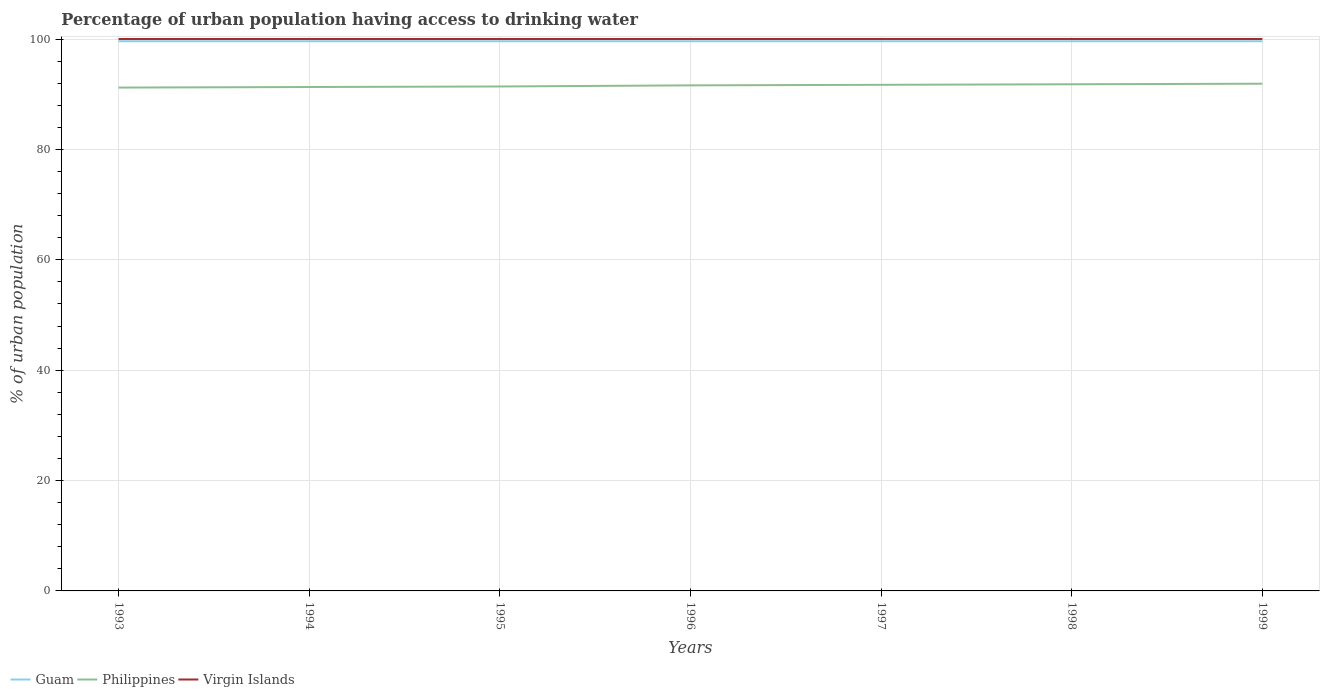Is the number of lines equal to the number of legend labels?
Your response must be concise. Yes. Across all years, what is the maximum percentage of urban population having access to drinking water in Philippines?
Your answer should be very brief. 91.2. How many years are there in the graph?
Give a very brief answer. 7. Does the graph contain grids?
Provide a short and direct response. Yes. Where does the legend appear in the graph?
Your response must be concise. Bottom left. How many legend labels are there?
Offer a terse response. 3. How are the legend labels stacked?
Offer a very short reply. Horizontal. What is the title of the graph?
Provide a short and direct response. Percentage of urban population having access to drinking water. Does "Niger" appear as one of the legend labels in the graph?
Make the answer very short. No. What is the label or title of the X-axis?
Ensure brevity in your answer.  Years. What is the label or title of the Y-axis?
Your response must be concise. % of urban population. What is the % of urban population of Guam in 1993?
Keep it short and to the point. 99.6. What is the % of urban population of Philippines in 1993?
Give a very brief answer. 91.2. What is the % of urban population in Guam in 1994?
Your response must be concise. 99.6. What is the % of urban population in Philippines in 1994?
Provide a succinct answer. 91.3. What is the % of urban population of Guam in 1995?
Give a very brief answer. 99.6. What is the % of urban population in Philippines in 1995?
Keep it short and to the point. 91.4. What is the % of urban population in Guam in 1996?
Your answer should be very brief. 99.6. What is the % of urban population of Philippines in 1996?
Give a very brief answer. 91.6. What is the % of urban population of Virgin Islands in 1996?
Provide a short and direct response. 100. What is the % of urban population in Guam in 1997?
Give a very brief answer. 99.6. What is the % of urban population in Philippines in 1997?
Your answer should be very brief. 91.7. What is the % of urban population of Guam in 1998?
Give a very brief answer. 99.6. What is the % of urban population in Philippines in 1998?
Your answer should be very brief. 91.8. What is the % of urban population of Virgin Islands in 1998?
Offer a very short reply. 100. What is the % of urban population of Guam in 1999?
Offer a very short reply. 99.6. What is the % of urban population in Philippines in 1999?
Keep it short and to the point. 91.9. What is the % of urban population of Virgin Islands in 1999?
Give a very brief answer. 100. Across all years, what is the maximum % of urban population in Guam?
Provide a short and direct response. 99.6. Across all years, what is the maximum % of urban population in Philippines?
Keep it short and to the point. 91.9. Across all years, what is the minimum % of urban population in Guam?
Provide a succinct answer. 99.6. Across all years, what is the minimum % of urban population of Philippines?
Give a very brief answer. 91.2. Across all years, what is the minimum % of urban population of Virgin Islands?
Give a very brief answer. 100. What is the total % of urban population in Guam in the graph?
Your answer should be very brief. 697.2. What is the total % of urban population of Philippines in the graph?
Keep it short and to the point. 640.9. What is the total % of urban population in Virgin Islands in the graph?
Make the answer very short. 700. What is the difference between the % of urban population in Guam in 1993 and that in 1994?
Your response must be concise. 0. What is the difference between the % of urban population in Virgin Islands in 1993 and that in 1994?
Offer a very short reply. 0. What is the difference between the % of urban population in Virgin Islands in 1993 and that in 1995?
Your answer should be very brief. 0. What is the difference between the % of urban population of Philippines in 1993 and that in 1996?
Your answer should be compact. -0.4. What is the difference between the % of urban population in Virgin Islands in 1993 and that in 1997?
Offer a very short reply. 0. What is the difference between the % of urban population of Virgin Islands in 1993 and that in 1998?
Keep it short and to the point. 0. What is the difference between the % of urban population of Philippines in 1993 and that in 1999?
Ensure brevity in your answer.  -0.7. What is the difference between the % of urban population in Virgin Islands in 1993 and that in 1999?
Your answer should be compact. 0. What is the difference between the % of urban population of Guam in 1994 and that in 1995?
Offer a very short reply. 0. What is the difference between the % of urban population in Philippines in 1994 and that in 1997?
Your answer should be very brief. -0.4. What is the difference between the % of urban population in Guam in 1994 and that in 1998?
Your answer should be very brief. 0. What is the difference between the % of urban population in Philippines in 1994 and that in 1998?
Offer a very short reply. -0.5. What is the difference between the % of urban population of Virgin Islands in 1994 and that in 1998?
Provide a succinct answer. 0. What is the difference between the % of urban population of Philippines in 1995 and that in 1996?
Offer a terse response. -0.2. What is the difference between the % of urban population in Guam in 1995 and that in 1997?
Keep it short and to the point. 0. What is the difference between the % of urban population in Philippines in 1995 and that in 1997?
Make the answer very short. -0.3. What is the difference between the % of urban population in Guam in 1995 and that in 1998?
Make the answer very short. 0. What is the difference between the % of urban population in Virgin Islands in 1995 and that in 1998?
Make the answer very short. 0. What is the difference between the % of urban population of Philippines in 1995 and that in 1999?
Your response must be concise. -0.5. What is the difference between the % of urban population in Philippines in 1996 and that in 1998?
Your answer should be compact. -0.2. What is the difference between the % of urban population of Guam in 1996 and that in 1999?
Offer a terse response. 0. What is the difference between the % of urban population in Philippines in 1996 and that in 1999?
Provide a succinct answer. -0.3. What is the difference between the % of urban population in Virgin Islands in 1996 and that in 1999?
Provide a succinct answer. 0. What is the difference between the % of urban population in Guam in 1997 and that in 1998?
Offer a terse response. 0. What is the difference between the % of urban population of Philippines in 1997 and that in 1998?
Provide a short and direct response. -0.1. What is the difference between the % of urban population of Virgin Islands in 1997 and that in 1998?
Provide a succinct answer. 0. What is the difference between the % of urban population in Philippines in 1997 and that in 1999?
Provide a short and direct response. -0.2. What is the difference between the % of urban population in Philippines in 1998 and that in 1999?
Your response must be concise. -0.1. What is the difference between the % of urban population in Philippines in 1993 and the % of urban population in Virgin Islands in 1994?
Make the answer very short. -8.8. What is the difference between the % of urban population in Guam in 1993 and the % of urban population in Philippines in 1995?
Provide a short and direct response. 8.2. What is the difference between the % of urban population in Guam in 1993 and the % of urban population in Virgin Islands in 1996?
Your response must be concise. -0.4. What is the difference between the % of urban population of Philippines in 1993 and the % of urban population of Virgin Islands in 1996?
Ensure brevity in your answer.  -8.8. What is the difference between the % of urban population in Guam in 1993 and the % of urban population in Philippines in 1997?
Your answer should be very brief. 7.9. What is the difference between the % of urban population in Philippines in 1993 and the % of urban population in Virgin Islands in 1997?
Provide a short and direct response. -8.8. What is the difference between the % of urban population of Guam in 1993 and the % of urban population of Virgin Islands in 1998?
Your response must be concise. -0.4. What is the difference between the % of urban population in Guam in 1993 and the % of urban population in Virgin Islands in 1999?
Provide a short and direct response. -0.4. What is the difference between the % of urban population of Philippines in 1993 and the % of urban population of Virgin Islands in 1999?
Ensure brevity in your answer.  -8.8. What is the difference between the % of urban population in Guam in 1994 and the % of urban population in Philippines in 1995?
Offer a terse response. 8.2. What is the difference between the % of urban population in Guam in 1994 and the % of urban population in Philippines in 1996?
Your answer should be compact. 8. What is the difference between the % of urban population of Guam in 1994 and the % of urban population of Virgin Islands in 1996?
Your answer should be very brief. -0.4. What is the difference between the % of urban population in Philippines in 1994 and the % of urban population in Virgin Islands in 1996?
Give a very brief answer. -8.7. What is the difference between the % of urban population in Guam in 1994 and the % of urban population in Philippines in 1997?
Provide a short and direct response. 7.9. What is the difference between the % of urban population of Guam in 1994 and the % of urban population of Virgin Islands in 1997?
Give a very brief answer. -0.4. What is the difference between the % of urban population in Philippines in 1994 and the % of urban population in Virgin Islands in 1997?
Your answer should be very brief. -8.7. What is the difference between the % of urban population in Guam in 1995 and the % of urban population in Virgin Islands in 1996?
Your response must be concise. -0.4. What is the difference between the % of urban population of Guam in 1995 and the % of urban population of Virgin Islands in 1997?
Give a very brief answer. -0.4. What is the difference between the % of urban population in Philippines in 1995 and the % of urban population in Virgin Islands in 1997?
Offer a very short reply. -8.6. What is the difference between the % of urban population in Guam in 1995 and the % of urban population in Philippines in 1998?
Ensure brevity in your answer.  7.8. What is the difference between the % of urban population of Guam in 1995 and the % of urban population of Virgin Islands in 1998?
Offer a terse response. -0.4. What is the difference between the % of urban population in Philippines in 1995 and the % of urban population in Virgin Islands in 1998?
Provide a succinct answer. -8.6. What is the difference between the % of urban population of Guam in 1995 and the % of urban population of Philippines in 1999?
Your answer should be compact. 7.7. What is the difference between the % of urban population of Philippines in 1995 and the % of urban population of Virgin Islands in 1999?
Offer a very short reply. -8.6. What is the difference between the % of urban population of Guam in 1996 and the % of urban population of Philippines in 1997?
Your answer should be compact. 7.9. What is the difference between the % of urban population in Philippines in 1996 and the % of urban population in Virgin Islands in 1997?
Your answer should be very brief. -8.4. What is the difference between the % of urban population in Philippines in 1996 and the % of urban population in Virgin Islands in 1998?
Keep it short and to the point. -8.4. What is the difference between the % of urban population of Guam in 1996 and the % of urban population of Philippines in 1999?
Make the answer very short. 7.7. What is the difference between the % of urban population in Guam in 1996 and the % of urban population in Virgin Islands in 1999?
Keep it short and to the point. -0.4. What is the difference between the % of urban population of Philippines in 1997 and the % of urban population of Virgin Islands in 1998?
Give a very brief answer. -8.3. What is the difference between the % of urban population in Philippines in 1997 and the % of urban population in Virgin Islands in 1999?
Ensure brevity in your answer.  -8.3. What is the difference between the % of urban population of Guam in 1998 and the % of urban population of Virgin Islands in 1999?
Offer a terse response. -0.4. What is the average % of urban population of Guam per year?
Your response must be concise. 99.6. What is the average % of urban population of Philippines per year?
Offer a terse response. 91.56. In the year 1994, what is the difference between the % of urban population of Guam and % of urban population of Philippines?
Keep it short and to the point. 8.3. In the year 1994, what is the difference between the % of urban population in Philippines and % of urban population in Virgin Islands?
Your answer should be compact. -8.7. In the year 1995, what is the difference between the % of urban population in Guam and % of urban population in Philippines?
Your answer should be compact. 8.2. In the year 1996, what is the difference between the % of urban population of Guam and % of urban population of Philippines?
Give a very brief answer. 8. In the year 1996, what is the difference between the % of urban population of Guam and % of urban population of Virgin Islands?
Your answer should be compact. -0.4. In the year 1996, what is the difference between the % of urban population of Philippines and % of urban population of Virgin Islands?
Give a very brief answer. -8.4. In the year 1997, what is the difference between the % of urban population of Guam and % of urban population of Virgin Islands?
Provide a short and direct response. -0.4. In the year 1998, what is the difference between the % of urban population in Philippines and % of urban population in Virgin Islands?
Ensure brevity in your answer.  -8.2. In the year 1999, what is the difference between the % of urban population of Guam and % of urban population of Philippines?
Keep it short and to the point. 7.7. In the year 1999, what is the difference between the % of urban population in Guam and % of urban population in Virgin Islands?
Give a very brief answer. -0.4. In the year 1999, what is the difference between the % of urban population of Philippines and % of urban population of Virgin Islands?
Make the answer very short. -8.1. What is the ratio of the % of urban population of Philippines in 1993 to that in 1994?
Ensure brevity in your answer.  1. What is the ratio of the % of urban population of Philippines in 1993 to that in 1995?
Give a very brief answer. 1. What is the ratio of the % of urban population in Philippines in 1993 to that in 1996?
Provide a succinct answer. 1. What is the ratio of the % of urban population of Virgin Islands in 1993 to that in 1996?
Give a very brief answer. 1. What is the ratio of the % of urban population of Guam in 1993 to that in 1997?
Offer a terse response. 1. What is the ratio of the % of urban population in Philippines in 1993 to that in 1997?
Provide a succinct answer. 0.99. What is the ratio of the % of urban population of Virgin Islands in 1993 to that in 1997?
Your answer should be compact. 1. What is the ratio of the % of urban population of Guam in 1993 to that in 1998?
Keep it short and to the point. 1. What is the ratio of the % of urban population in Philippines in 1993 to that in 1998?
Make the answer very short. 0.99. What is the ratio of the % of urban population of Virgin Islands in 1993 to that in 1998?
Provide a short and direct response. 1. What is the ratio of the % of urban population of Guam in 1993 to that in 1999?
Ensure brevity in your answer.  1. What is the ratio of the % of urban population in Virgin Islands in 1993 to that in 1999?
Offer a terse response. 1. What is the ratio of the % of urban population in Guam in 1994 to that in 1995?
Offer a very short reply. 1. What is the ratio of the % of urban population of Philippines in 1994 to that in 1995?
Ensure brevity in your answer.  1. What is the ratio of the % of urban population in Virgin Islands in 1994 to that in 1996?
Give a very brief answer. 1. What is the ratio of the % of urban population in Virgin Islands in 1994 to that in 1997?
Provide a succinct answer. 1. What is the ratio of the % of urban population of Philippines in 1994 to that in 1998?
Your response must be concise. 0.99. What is the ratio of the % of urban population in Guam in 1994 to that in 1999?
Your response must be concise. 1. What is the ratio of the % of urban population in Guam in 1995 to that in 1996?
Provide a succinct answer. 1. What is the ratio of the % of urban population of Philippines in 1995 to that in 1996?
Make the answer very short. 1. What is the ratio of the % of urban population of Virgin Islands in 1995 to that in 1996?
Your answer should be very brief. 1. What is the ratio of the % of urban population of Philippines in 1995 to that in 1997?
Your answer should be compact. 1. What is the ratio of the % of urban population of Guam in 1995 to that in 1998?
Your response must be concise. 1. What is the ratio of the % of urban population of Virgin Islands in 1995 to that in 1999?
Give a very brief answer. 1. What is the ratio of the % of urban population of Guam in 1996 to that in 1998?
Give a very brief answer. 1. What is the ratio of the % of urban population of Philippines in 1996 to that in 1998?
Your response must be concise. 1. What is the ratio of the % of urban population in Guam in 1996 to that in 1999?
Your answer should be compact. 1. What is the ratio of the % of urban population in Virgin Islands in 1996 to that in 1999?
Ensure brevity in your answer.  1. What is the ratio of the % of urban population in Guam in 1997 to that in 1998?
Keep it short and to the point. 1. What is the ratio of the % of urban population of Virgin Islands in 1997 to that in 1998?
Offer a terse response. 1. What is the ratio of the % of urban population in Guam in 1998 to that in 1999?
Give a very brief answer. 1. What is the ratio of the % of urban population in Virgin Islands in 1998 to that in 1999?
Your response must be concise. 1. What is the difference between the highest and the second highest % of urban population in Guam?
Keep it short and to the point. 0. What is the difference between the highest and the second highest % of urban population in Philippines?
Give a very brief answer. 0.1. What is the difference between the highest and the second highest % of urban population of Virgin Islands?
Your answer should be very brief. 0. What is the difference between the highest and the lowest % of urban population of Guam?
Your answer should be very brief. 0. What is the difference between the highest and the lowest % of urban population in Philippines?
Provide a succinct answer. 0.7. 